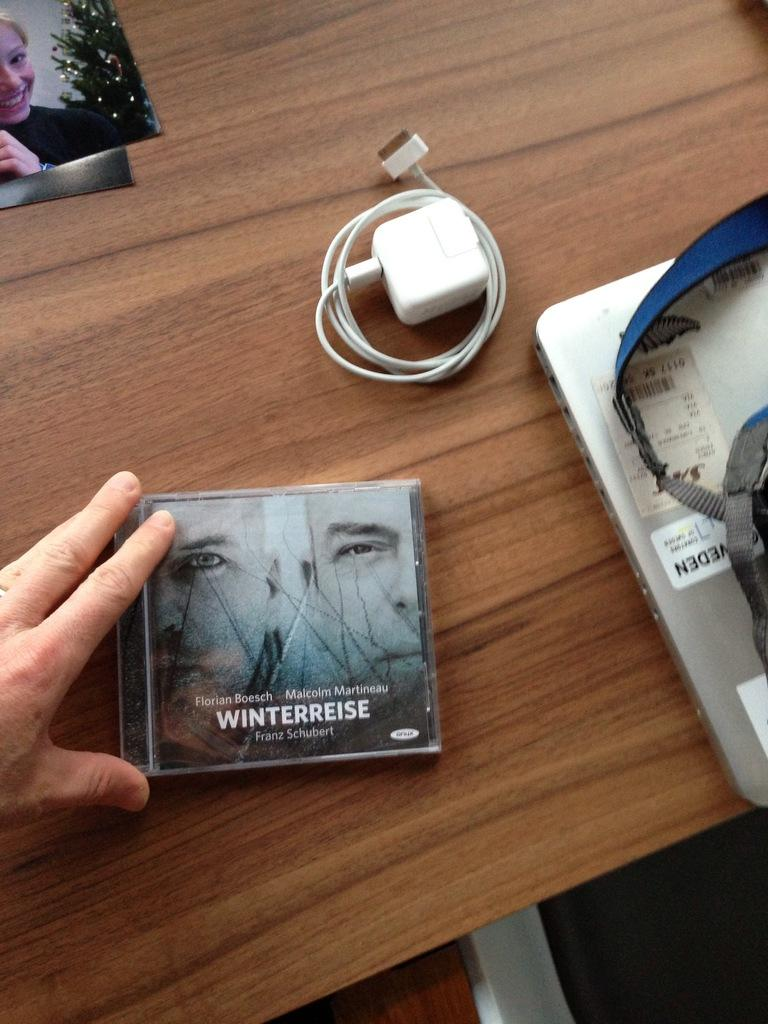<image>
Summarize the visual content of the image. A cd for winterreise sitting on a wood table. 